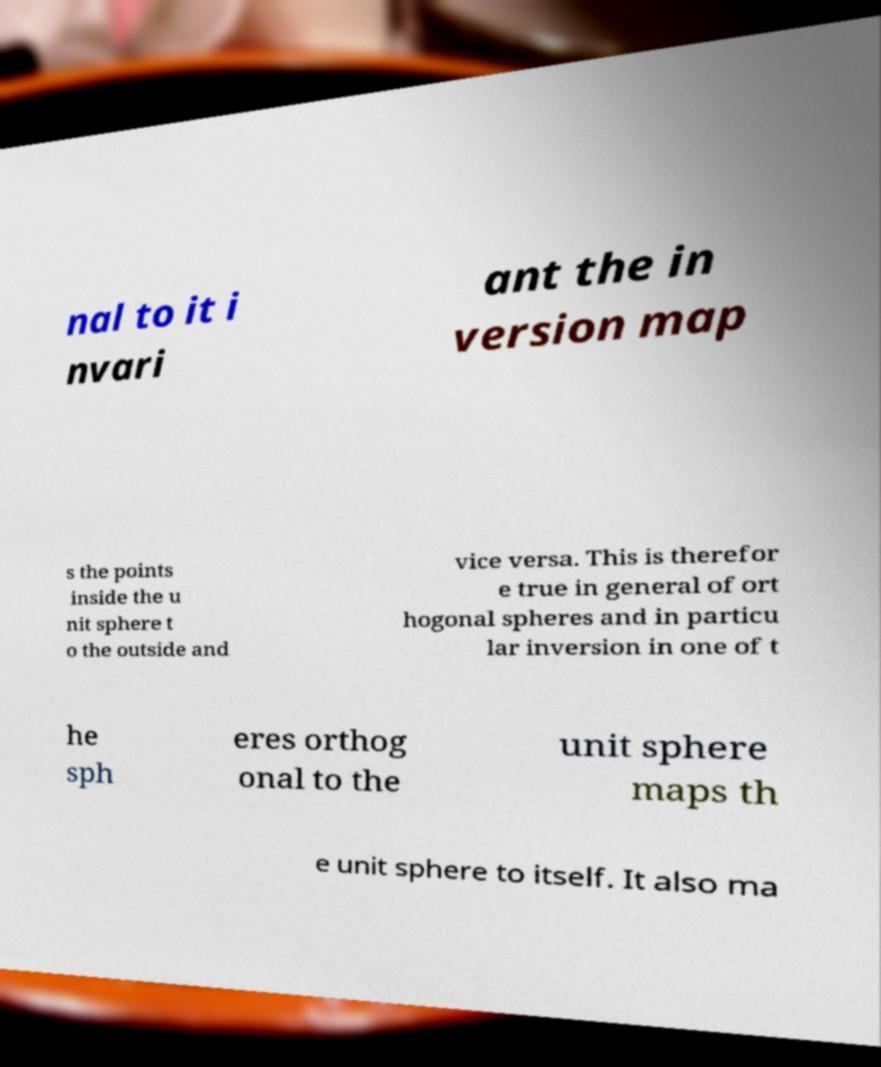Could you extract and type out the text from this image? nal to it i nvari ant the in version map s the points inside the u nit sphere t o the outside and vice versa. This is therefor e true in general of ort hogonal spheres and in particu lar inversion in one of t he sph eres orthog onal to the unit sphere maps th e unit sphere to itself. It also ma 